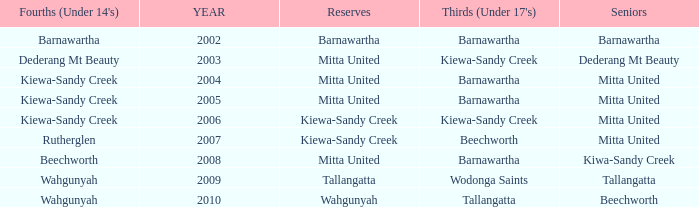Which Fourths (Under 14's) have Seniors of dederang mt beauty? Dederang Mt Beauty. 